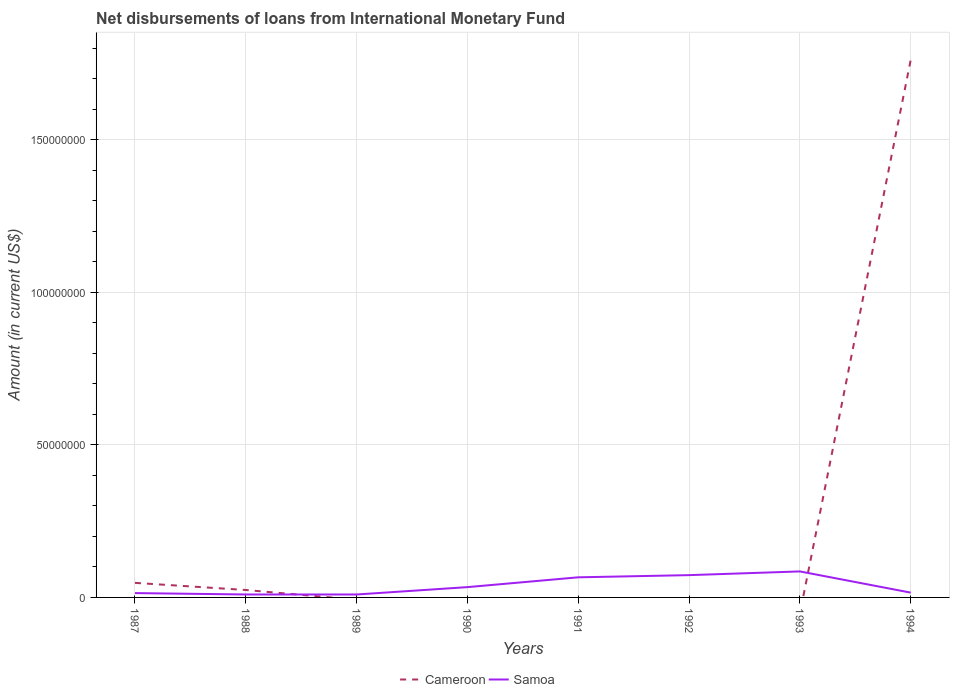How many different coloured lines are there?
Your answer should be very brief. 2. Does the line corresponding to Cameroon intersect with the line corresponding to Samoa?
Keep it short and to the point. Yes. Is the number of lines equal to the number of legend labels?
Give a very brief answer. No. Across all years, what is the maximum amount of loans disbursed in Samoa?
Ensure brevity in your answer.  9.62e+05. What is the total amount of loans disbursed in Samoa in the graph?
Offer a terse response. 1000. What is the difference between the highest and the second highest amount of loans disbursed in Samoa?
Your answer should be very brief. 7.56e+06. What is the difference between the highest and the lowest amount of loans disbursed in Samoa?
Make the answer very short. 3. How many lines are there?
Offer a very short reply. 2. How many years are there in the graph?
Provide a succinct answer. 8. Does the graph contain grids?
Your response must be concise. Yes. How many legend labels are there?
Your answer should be very brief. 2. How are the legend labels stacked?
Keep it short and to the point. Horizontal. What is the title of the graph?
Provide a short and direct response. Net disbursements of loans from International Monetary Fund. Does "Cameroon" appear as one of the legend labels in the graph?
Make the answer very short. Yes. What is the label or title of the Y-axis?
Offer a very short reply. Amount (in current US$). What is the Amount (in current US$) in Cameroon in 1987?
Provide a short and direct response. 4.77e+06. What is the Amount (in current US$) in Samoa in 1987?
Your answer should be compact. 1.42e+06. What is the Amount (in current US$) in Cameroon in 1988?
Provide a short and direct response. 2.44e+06. What is the Amount (in current US$) in Samoa in 1988?
Your answer should be very brief. 9.63e+05. What is the Amount (in current US$) of Samoa in 1989?
Give a very brief answer. 9.62e+05. What is the Amount (in current US$) in Cameroon in 1990?
Keep it short and to the point. 0. What is the Amount (in current US$) in Samoa in 1990?
Give a very brief answer. 3.38e+06. What is the Amount (in current US$) of Samoa in 1991?
Offer a very short reply. 6.59e+06. What is the Amount (in current US$) of Samoa in 1992?
Give a very brief answer. 7.30e+06. What is the Amount (in current US$) of Cameroon in 1993?
Give a very brief answer. 0. What is the Amount (in current US$) in Samoa in 1993?
Provide a succinct answer. 8.52e+06. What is the Amount (in current US$) of Cameroon in 1994?
Offer a terse response. 1.76e+08. What is the Amount (in current US$) in Samoa in 1994?
Offer a terse response. 1.57e+06. Across all years, what is the maximum Amount (in current US$) in Cameroon?
Ensure brevity in your answer.  1.76e+08. Across all years, what is the maximum Amount (in current US$) of Samoa?
Your response must be concise. 8.52e+06. Across all years, what is the minimum Amount (in current US$) in Cameroon?
Keep it short and to the point. 0. Across all years, what is the minimum Amount (in current US$) of Samoa?
Your answer should be very brief. 9.62e+05. What is the total Amount (in current US$) in Cameroon in the graph?
Provide a short and direct response. 1.83e+08. What is the total Amount (in current US$) in Samoa in the graph?
Your response must be concise. 3.07e+07. What is the difference between the Amount (in current US$) in Cameroon in 1987 and that in 1988?
Provide a short and direct response. 2.33e+06. What is the difference between the Amount (in current US$) of Samoa in 1987 and that in 1988?
Your response must be concise. 4.54e+05. What is the difference between the Amount (in current US$) of Samoa in 1987 and that in 1989?
Offer a terse response. 4.55e+05. What is the difference between the Amount (in current US$) in Samoa in 1987 and that in 1990?
Give a very brief answer. -1.96e+06. What is the difference between the Amount (in current US$) in Samoa in 1987 and that in 1991?
Your response must be concise. -5.17e+06. What is the difference between the Amount (in current US$) of Samoa in 1987 and that in 1992?
Provide a short and direct response. -5.89e+06. What is the difference between the Amount (in current US$) in Samoa in 1987 and that in 1993?
Give a very brief answer. -7.10e+06. What is the difference between the Amount (in current US$) in Cameroon in 1987 and that in 1994?
Your answer should be compact. -1.71e+08. What is the difference between the Amount (in current US$) in Samoa in 1987 and that in 1994?
Your answer should be compact. -1.56e+05. What is the difference between the Amount (in current US$) in Samoa in 1988 and that in 1989?
Offer a terse response. 1000. What is the difference between the Amount (in current US$) of Samoa in 1988 and that in 1990?
Your response must be concise. -2.41e+06. What is the difference between the Amount (in current US$) in Samoa in 1988 and that in 1991?
Make the answer very short. -5.63e+06. What is the difference between the Amount (in current US$) in Samoa in 1988 and that in 1992?
Provide a succinct answer. -6.34e+06. What is the difference between the Amount (in current US$) in Samoa in 1988 and that in 1993?
Ensure brevity in your answer.  -7.56e+06. What is the difference between the Amount (in current US$) of Cameroon in 1988 and that in 1994?
Ensure brevity in your answer.  -1.74e+08. What is the difference between the Amount (in current US$) in Samoa in 1988 and that in 1994?
Your answer should be compact. -6.10e+05. What is the difference between the Amount (in current US$) of Samoa in 1989 and that in 1990?
Provide a succinct answer. -2.41e+06. What is the difference between the Amount (in current US$) of Samoa in 1989 and that in 1991?
Your response must be concise. -5.63e+06. What is the difference between the Amount (in current US$) in Samoa in 1989 and that in 1992?
Your response must be concise. -6.34e+06. What is the difference between the Amount (in current US$) in Samoa in 1989 and that in 1993?
Your answer should be very brief. -7.56e+06. What is the difference between the Amount (in current US$) of Samoa in 1989 and that in 1994?
Your response must be concise. -6.11e+05. What is the difference between the Amount (in current US$) in Samoa in 1990 and that in 1991?
Provide a short and direct response. -3.22e+06. What is the difference between the Amount (in current US$) of Samoa in 1990 and that in 1992?
Keep it short and to the point. -3.93e+06. What is the difference between the Amount (in current US$) of Samoa in 1990 and that in 1993?
Your response must be concise. -5.14e+06. What is the difference between the Amount (in current US$) in Samoa in 1990 and that in 1994?
Ensure brevity in your answer.  1.80e+06. What is the difference between the Amount (in current US$) in Samoa in 1991 and that in 1992?
Your response must be concise. -7.13e+05. What is the difference between the Amount (in current US$) in Samoa in 1991 and that in 1993?
Give a very brief answer. -1.93e+06. What is the difference between the Amount (in current US$) in Samoa in 1991 and that in 1994?
Make the answer very short. 5.02e+06. What is the difference between the Amount (in current US$) in Samoa in 1992 and that in 1993?
Give a very brief answer. -1.22e+06. What is the difference between the Amount (in current US$) in Samoa in 1992 and that in 1994?
Provide a succinct answer. 5.73e+06. What is the difference between the Amount (in current US$) of Samoa in 1993 and that in 1994?
Provide a succinct answer. 6.95e+06. What is the difference between the Amount (in current US$) of Cameroon in 1987 and the Amount (in current US$) of Samoa in 1988?
Your answer should be compact. 3.81e+06. What is the difference between the Amount (in current US$) of Cameroon in 1987 and the Amount (in current US$) of Samoa in 1989?
Provide a short and direct response. 3.81e+06. What is the difference between the Amount (in current US$) in Cameroon in 1987 and the Amount (in current US$) in Samoa in 1990?
Your response must be concise. 1.39e+06. What is the difference between the Amount (in current US$) of Cameroon in 1987 and the Amount (in current US$) of Samoa in 1991?
Offer a very short reply. -1.82e+06. What is the difference between the Amount (in current US$) in Cameroon in 1987 and the Amount (in current US$) in Samoa in 1992?
Your answer should be very brief. -2.54e+06. What is the difference between the Amount (in current US$) in Cameroon in 1987 and the Amount (in current US$) in Samoa in 1993?
Offer a terse response. -3.75e+06. What is the difference between the Amount (in current US$) in Cameroon in 1987 and the Amount (in current US$) in Samoa in 1994?
Provide a short and direct response. 3.20e+06. What is the difference between the Amount (in current US$) of Cameroon in 1988 and the Amount (in current US$) of Samoa in 1989?
Ensure brevity in your answer.  1.48e+06. What is the difference between the Amount (in current US$) of Cameroon in 1988 and the Amount (in current US$) of Samoa in 1990?
Provide a succinct answer. -9.39e+05. What is the difference between the Amount (in current US$) of Cameroon in 1988 and the Amount (in current US$) of Samoa in 1991?
Make the answer very short. -4.15e+06. What is the difference between the Amount (in current US$) in Cameroon in 1988 and the Amount (in current US$) in Samoa in 1992?
Provide a short and direct response. -4.87e+06. What is the difference between the Amount (in current US$) in Cameroon in 1988 and the Amount (in current US$) in Samoa in 1993?
Provide a short and direct response. -6.08e+06. What is the difference between the Amount (in current US$) of Cameroon in 1988 and the Amount (in current US$) of Samoa in 1994?
Provide a succinct answer. 8.64e+05. What is the average Amount (in current US$) of Cameroon per year?
Your response must be concise. 2.29e+07. What is the average Amount (in current US$) of Samoa per year?
Offer a terse response. 3.84e+06. In the year 1987, what is the difference between the Amount (in current US$) of Cameroon and Amount (in current US$) of Samoa?
Give a very brief answer. 3.35e+06. In the year 1988, what is the difference between the Amount (in current US$) in Cameroon and Amount (in current US$) in Samoa?
Make the answer very short. 1.47e+06. In the year 1994, what is the difference between the Amount (in current US$) in Cameroon and Amount (in current US$) in Samoa?
Offer a terse response. 1.75e+08. What is the ratio of the Amount (in current US$) of Cameroon in 1987 to that in 1988?
Keep it short and to the point. 1.96. What is the ratio of the Amount (in current US$) of Samoa in 1987 to that in 1988?
Ensure brevity in your answer.  1.47. What is the ratio of the Amount (in current US$) in Samoa in 1987 to that in 1989?
Provide a short and direct response. 1.47. What is the ratio of the Amount (in current US$) of Samoa in 1987 to that in 1990?
Offer a very short reply. 0.42. What is the ratio of the Amount (in current US$) in Samoa in 1987 to that in 1991?
Provide a short and direct response. 0.21. What is the ratio of the Amount (in current US$) of Samoa in 1987 to that in 1992?
Keep it short and to the point. 0.19. What is the ratio of the Amount (in current US$) of Samoa in 1987 to that in 1993?
Your answer should be very brief. 0.17. What is the ratio of the Amount (in current US$) in Cameroon in 1987 to that in 1994?
Give a very brief answer. 0.03. What is the ratio of the Amount (in current US$) in Samoa in 1987 to that in 1994?
Offer a very short reply. 0.9. What is the ratio of the Amount (in current US$) of Samoa in 1988 to that in 1990?
Your response must be concise. 0.29. What is the ratio of the Amount (in current US$) in Samoa in 1988 to that in 1991?
Keep it short and to the point. 0.15. What is the ratio of the Amount (in current US$) in Samoa in 1988 to that in 1992?
Your answer should be very brief. 0.13. What is the ratio of the Amount (in current US$) of Samoa in 1988 to that in 1993?
Keep it short and to the point. 0.11. What is the ratio of the Amount (in current US$) in Cameroon in 1988 to that in 1994?
Offer a very short reply. 0.01. What is the ratio of the Amount (in current US$) in Samoa in 1988 to that in 1994?
Provide a short and direct response. 0.61. What is the ratio of the Amount (in current US$) of Samoa in 1989 to that in 1990?
Make the answer very short. 0.28. What is the ratio of the Amount (in current US$) in Samoa in 1989 to that in 1991?
Keep it short and to the point. 0.15. What is the ratio of the Amount (in current US$) in Samoa in 1989 to that in 1992?
Your answer should be compact. 0.13. What is the ratio of the Amount (in current US$) of Samoa in 1989 to that in 1993?
Provide a short and direct response. 0.11. What is the ratio of the Amount (in current US$) of Samoa in 1989 to that in 1994?
Ensure brevity in your answer.  0.61. What is the ratio of the Amount (in current US$) in Samoa in 1990 to that in 1991?
Offer a very short reply. 0.51. What is the ratio of the Amount (in current US$) of Samoa in 1990 to that in 1992?
Offer a very short reply. 0.46. What is the ratio of the Amount (in current US$) of Samoa in 1990 to that in 1993?
Provide a short and direct response. 0.4. What is the ratio of the Amount (in current US$) of Samoa in 1990 to that in 1994?
Provide a short and direct response. 2.15. What is the ratio of the Amount (in current US$) in Samoa in 1991 to that in 1992?
Give a very brief answer. 0.9. What is the ratio of the Amount (in current US$) of Samoa in 1991 to that in 1993?
Keep it short and to the point. 0.77. What is the ratio of the Amount (in current US$) in Samoa in 1991 to that in 1994?
Your answer should be very brief. 4.19. What is the ratio of the Amount (in current US$) in Samoa in 1992 to that in 1993?
Your response must be concise. 0.86. What is the ratio of the Amount (in current US$) in Samoa in 1992 to that in 1994?
Give a very brief answer. 4.64. What is the ratio of the Amount (in current US$) in Samoa in 1993 to that in 1994?
Ensure brevity in your answer.  5.42. What is the difference between the highest and the second highest Amount (in current US$) of Cameroon?
Offer a very short reply. 1.71e+08. What is the difference between the highest and the second highest Amount (in current US$) in Samoa?
Provide a short and direct response. 1.22e+06. What is the difference between the highest and the lowest Amount (in current US$) in Cameroon?
Give a very brief answer. 1.76e+08. What is the difference between the highest and the lowest Amount (in current US$) of Samoa?
Make the answer very short. 7.56e+06. 